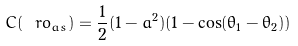Convert formula to latex. <formula><loc_0><loc_0><loc_500><loc_500>C ( \ r o _ { a s } ) = \frac { 1 } { 2 } ( 1 - a ^ { 2 } ) ( 1 - \cos ( \theta _ { 1 } - \theta _ { 2 } ) )</formula> 